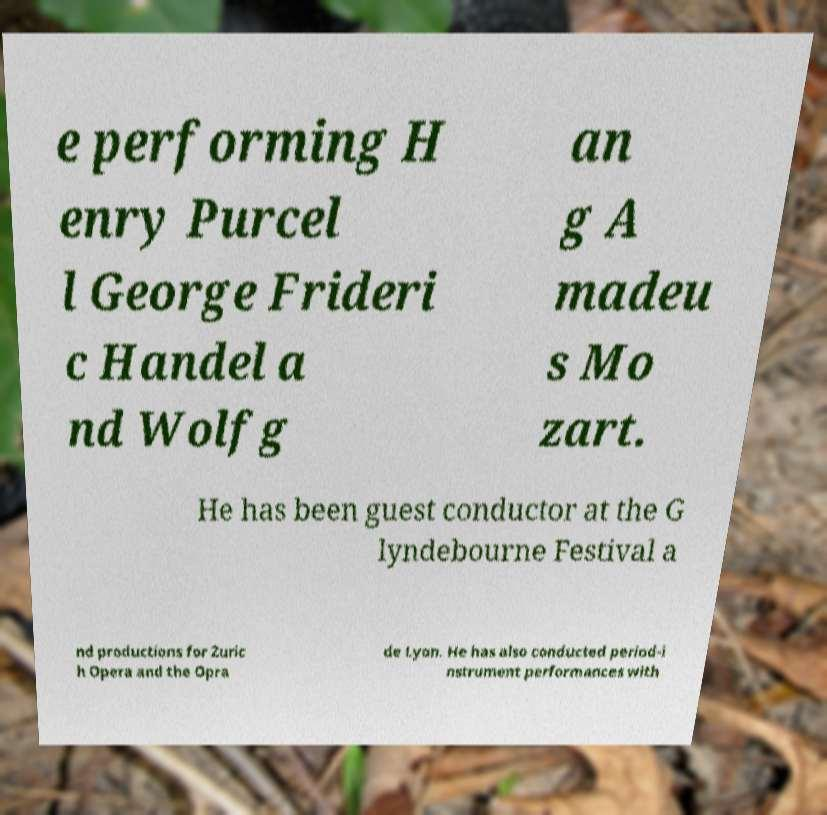Can you read and provide the text displayed in the image?This photo seems to have some interesting text. Can you extract and type it out for me? e performing H enry Purcel l George Frideri c Handel a nd Wolfg an g A madeu s Mo zart. He has been guest conductor at the G lyndebourne Festival a nd productions for Zuric h Opera and the Opra de Lyon. He has also conducted period-i nstrument performances with 